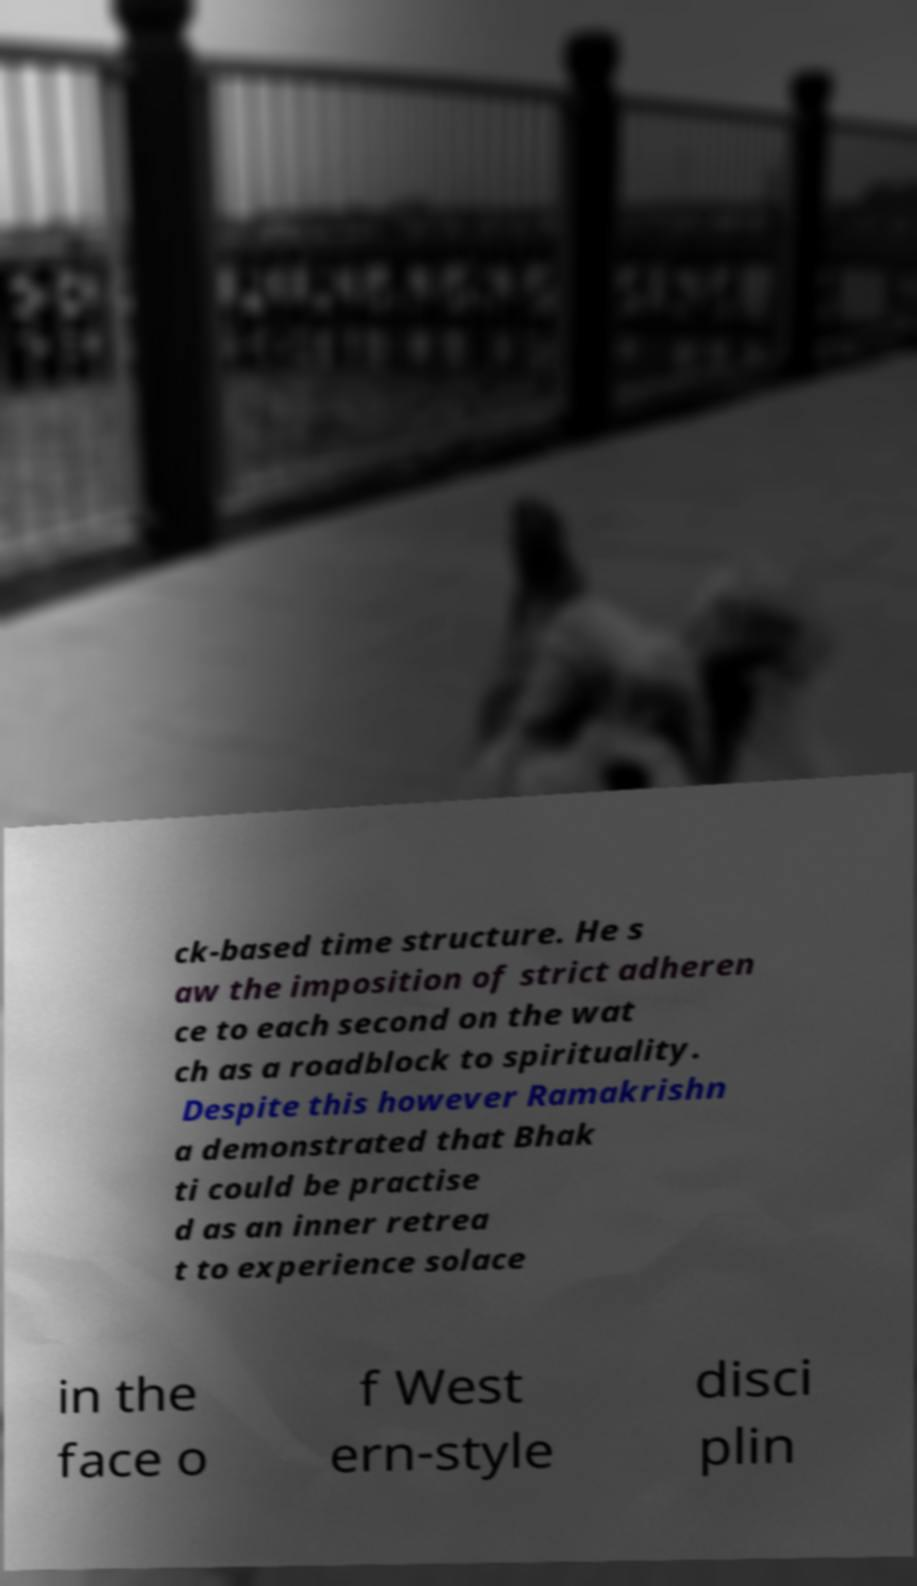There's text embedded in this image that I need extracted. Can you transcribe it verbatim? ck-based time structure. He s aw the imposition of strict adheren ce to each second on the wat ch as a roadblock to spirituality. Despite this however Ramakrishn a demonstrated that Bhak ti could be practise d as an inner retrea t to experience solace in the face o f West ern-style disci plin 